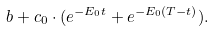Convert formula to latex. <formula><loc_0><loc_0><loc_500><loc_500>b + c _ { 0 } \cdot ( e ^ { - E _ { 0 } t } + e ^ { - E _ { 0 } ( T - t ) } ) .</formula> 